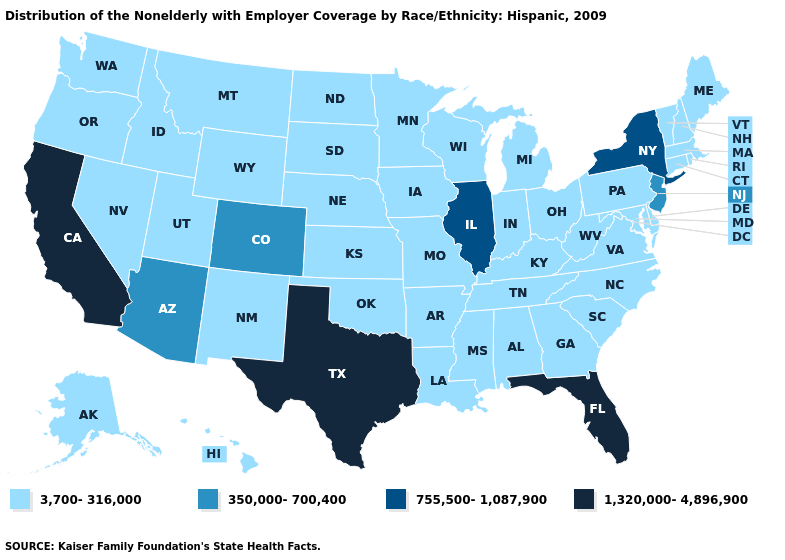Name the states that have a value in the range 1,320,000-4,896,900?
Keep it brief. California, Florida, Texas. Name the states that have a value in the range 1,320,000-4,896,900?
Give a very brief answer. California, Florida, Texas. Name the states that have a value in the range 3,700-316,000?
Concise answer only. Alabama, Alaska, Arkansas, Connecticut, Delaware, Georgia, Hawaii, Idaho, Indiana, Iowa, Kansas, Kentucky, Louisiana, Maine, Maryland, Massachusetts, Michigan, Minnesota, Mississippi, Missouri, Montana, Nebraska, Nevada, New Hampshire, New Mexico, North Carolina, North Dakota, Ohio, Oklahoma, Oregon, Pennsylvania, Rhode Island, South Carolina, South Dakota, Tennessee, Utah, Vermont, Virginia, Washington, West Virginia, Wisconsin, Wyoming. Does the map have missing data?
Answer briefly. No. Among the states that border Wisconsin , which have the highest value?
Give a very brief answer. Illinois. Name the states that have a value in the range 3,700-316,000?
Be succinct. Alabama, Alaska, Arkansas, Connecticut, Delaware, Georgia, Hawaii, Idaho, Indiana, Iowa, Kansas, Kentucky, Louisiana, Maine, Maryland, Massachusetts, Michigan, Minnesota, Mississippi, Missouri, Montana, Nebraska, Nevada, New Hampshire, New Mexico, North Carolina, North Dakota, Ohio, Oklahoma, Oregon, Pennsylvania, Rhode Island, South Carolina, South Dakota, Tennessee, Utah, Vermont, Virginia, Washington, West Virginia, Wisconsin, Wyoming. What is the value of Maryland?
Short answer required. 3,700-316,000. Among the states that border Connecticut , which have the lowest value?
Be succinct. Massachusetts, Rhode Island. What is the value of New Jersey?
Short answer required. 350,000-700,400. Is the legend a continuous bar?
Short answer required. No. Name the states that have a value in the range 755,500-1,087,900?
Write a very short answer. Illinois, New York. Is the legend a continuous bar?
Short answer required. No. What is the highest value in states that border Nebraska?
Short answer required. 350,000-700,400. Name the states that have a value in the range 1,320,000-4,896,900?
Answer briefly. California, Florida, Texas. What is the value of Kentucky?
Give a very brief answer. 3,700-316,000. 